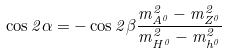<formula> <loc_0><loc_0><loc_500><loc_500>\cos 2 \alpha = - \cos 2 \beta \frac { m _ { A ^ { 0 } } ^ { 2 } - m _ { Z ^ { 0 } } ^ { 2 } } { m _ { H ^ { 0 } } ^ { 2 } - m _ { h ^ { 0 } } ^ { 2 } }</formula> 